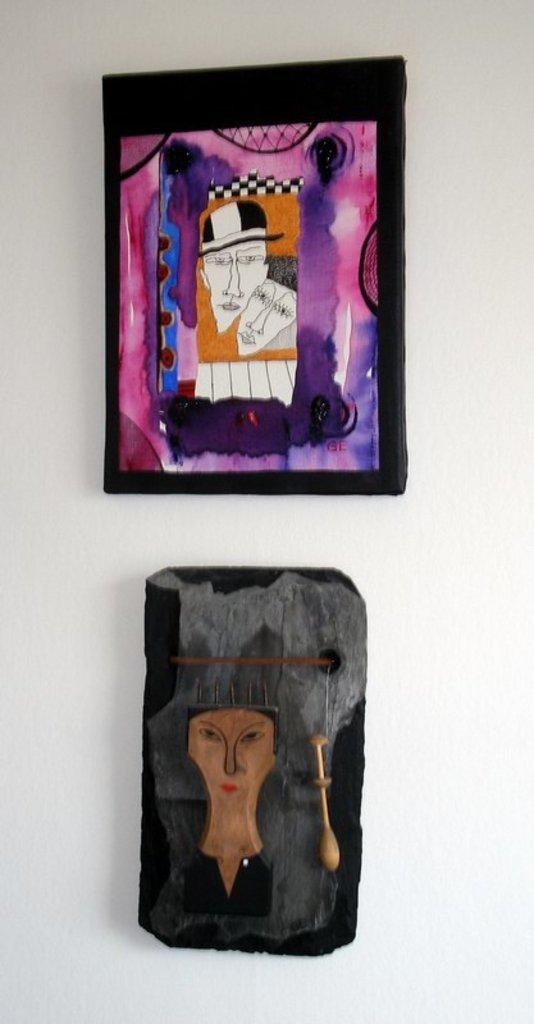What objects are present in the image that are related to photographs? There are two photo frames in the image. Where are the photo frames located? The photo frames are on a white wall. What type of camera can be seen in the image? There is no camera present in the image; it only features two photo frames on a white wall. Is there a mark on the wall next to the photo frames? There is no mention of a mark on the wall next to the photo frames in the provided facts. 